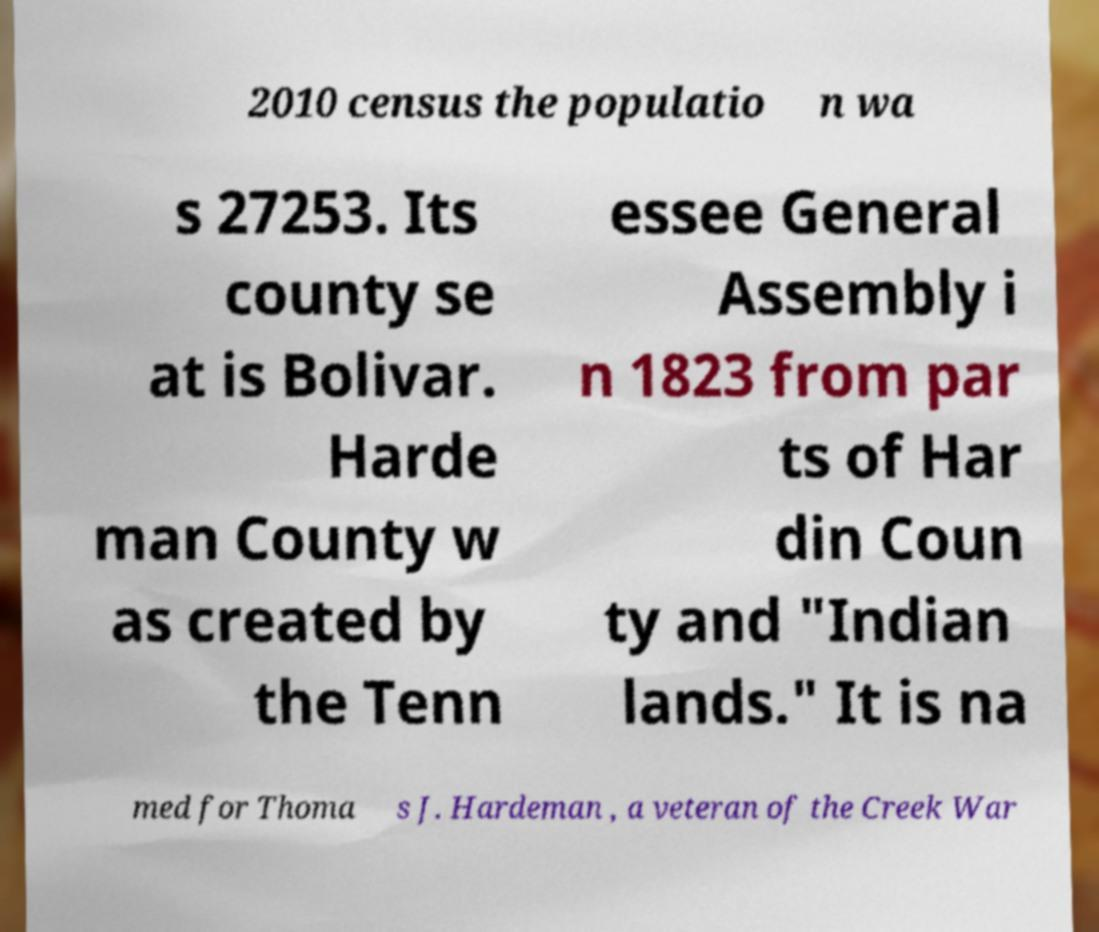I need the written content from this picture converted into text. Can you do that? 2010 census the populatio n wa s 27253. Its county se at is Bolivar. Harde man County w as created by the Tenn essee General Assembly i n 1823 from par ts of Har din Coun ty and "Indian lands." It is na med for Thoma s J. Hardeman , a veteran of the Creek War 